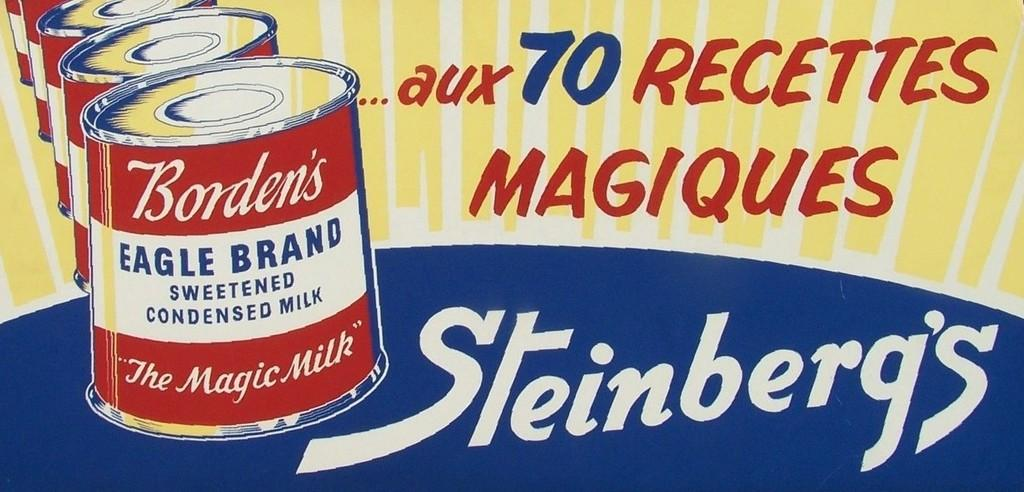<image>
Relay a brief, clear account of the picture shown. A sign has a Steinberg's logo on it in white. 